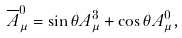<formula> <loc_0><loc_0><loc_500><loc_500>\overline { A } _ { \mu } ^ { 0 } = \sin \theta A _ { \mu } ^ { 3 } + \cos \theta A _ { \mu } ^ { 0 } ,</formula> 